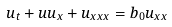<formula> <loc_0><loc_0><loc_500><loc_500>u _ { t } + u u _ { x } + u _ { x x x } = b _ { 0 } u _ { x x }</formula> 